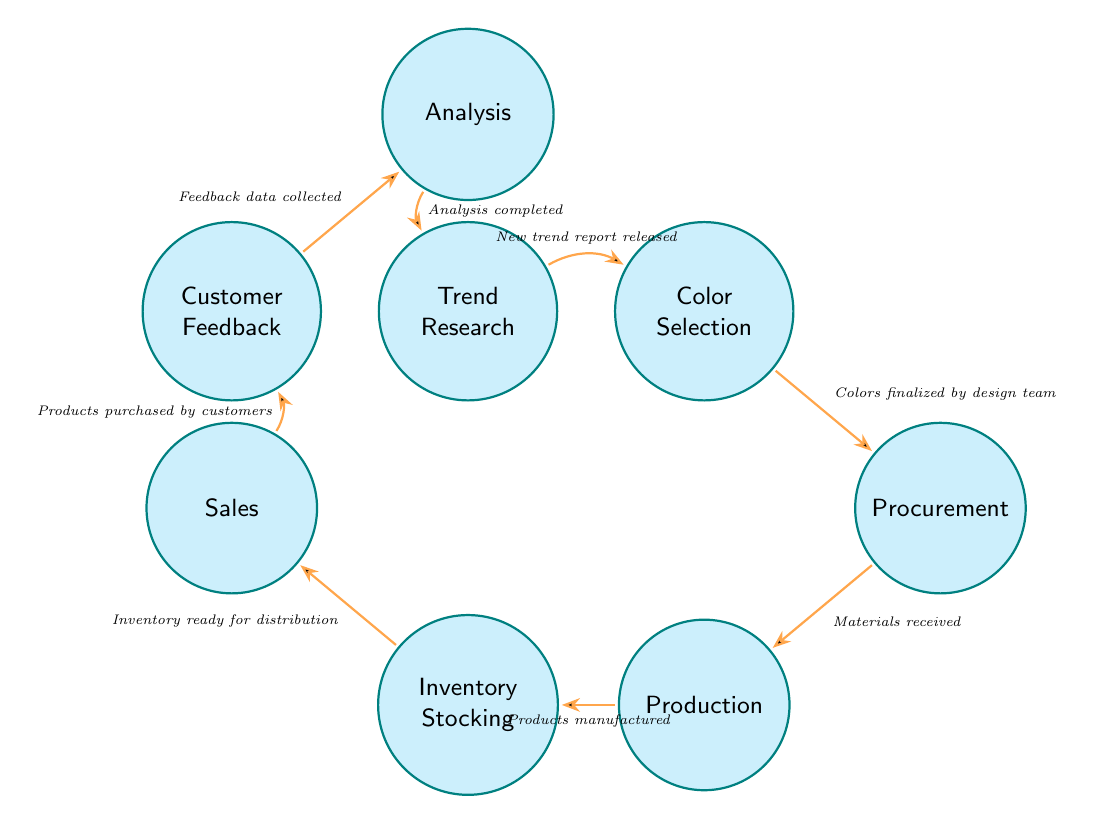What is the first state in the inventory management cycle? The diagram indicates that "Trend Research" is the initial state where the process begins with researching upcoming color trends. This is the top node in the diagram.
Answer: Trend Research How many states are present in the diagram? Counting the states listed in the diagram shows there are eight different states present, including Trend Research, Color Selection, Procurement, Production, Inventory Stocking, Sales, Customer Feedback, and Analysis.
Answer: Eight Which state follows "Sales"? Looking at the transitions, the state that comes after "Sales" is "Customer Feedback", as indicated by the arrow leading from Sales to Customer Feedback.
Answer: Customer Feedback What condition leads from "Production" to "Inventory Stocking"? The condition linking "Production" to "Inventory Stocking" is specified as "Products manufactured." This condition indicates that the transition occurs when the manufacturing process is completed.
Answer: Products manufactured What is the last state in the cycle before returning to the first state? The diagram shows that the last state leading back to "Trend Research" is "Analysis." The transition from Analysis goes back to Trend Research when the analysis is completed.
Answer: Analysis How many transitions are created from the "Procurement" state? The diagram displays one transition originating from "Procurement" which moves to "Production" upon the condition of having materials received. There are no other arrows leading out of Procurement.
Answer: One What happens after "Customer Feedback" in the diagram? The next step flowing from "Customer Feedback" is to "Analysis." This transition occurs after the feedback data is collected as indicated in the diagram.
Answer: Analysis Which two states can be connected directly without any intermediary? The states "Trend Research" and "Color Selection" can be connected directly as there is a transition from Trend Research to Color Selection without any intermediary state.
Answer: Trend Research and Color Selection 